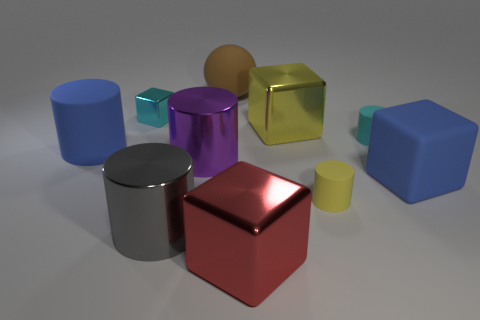There is a tiny object that is both to the left of the cyan matte cylinder and in front of the large yellow cube; what is its color?
Offer a very short reply. Yellow. Are there any big objects that have the same color as the rubber sphere?
Your answer should be very brief. No. What is the color of the large thing on the right side of the tiny yellow rubber cylinder?
Keep it short and to the point. Blue. There is a large block in front of the big gray metal thing; is there a large purple metallic object that is in front of it?
Give a very brief answer. No. There is a tiny metal object; is it the same color as the metallic cylinder behind the rubber block?
Ensure brevity in your answer.  No. Is there another gray object that has the same material as the big gray object?
Your answer should be compact. No. How many big rubber cubes are there?
Offer a terse response. 1. The large cylinder that is in front of the blue matte object that is right of the red cube is made of what material?
Your response must be concise. Metal. What is the color of the big cylinder that is made of the same material as the brown sphere?
Make the answer very short. Blue. What is the shape of the other small object that is the same color as the small shiny object?
Offer a very short reply. Cylinder. 